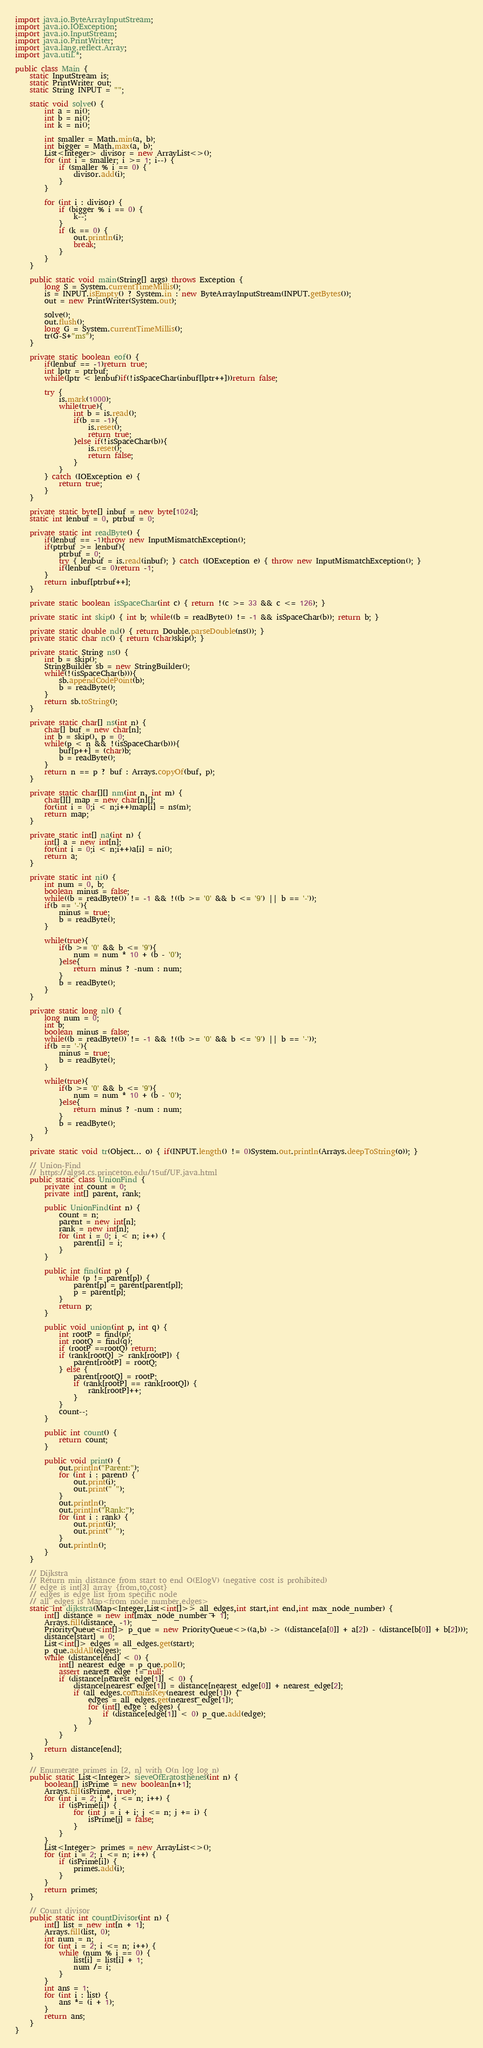Convert code to text. <code><loc_0><loc_0><loc_500><loc_500><_Java_>import java.io.ByteArrayInputStream;
import java.io.IOException;
import java.io.InputStream;
import java.io.PrintWriter;
import java.lang.reflect.Array;
import java.util.*;

public class Main {
    static InputStream is;
    static PrintWriter out;
    static String INPUT = "";

    static void solve() {
        int a = ni();
        int b = ni();
        int k = ni();

        int smaller = Math.min(a, b);
        int bigger = Math.max(a, b);
        List<Integer> divisor = new ArrayList<>();
        for (int i = smaller; i >= 1; i--) {
            if (smaller % i == 0) {
                divisor.add(i);
            }
        }

        for (int i : divisor) {
            if (bigger % i == 0) {
                k--;
            }
            if (k == 0) {
                out.println(i);
                break;
            }
        }
    }

    public static void main(String[] args) throws Exception {
        long S = System.currentTimeMillis();
        is = INPUT.isEmpty() ? System.in : new ByteArrayInputStream(INPUT.getBytes());
        out = new PrintWriter(System.out);

        solve();
        out.flush();
        long G = System.currentTimeMillis();
        tr(G-S+"ms");
    }

    private static boolean eof() {
        if(lenbuf == -1)return true;
        int lptr = ptrbuf;
        while(lptr < lenbuf)if(!isSpaceChar(inbuf[lptr++]))return false;

        try {
            is.mark(1000);
            while(true){
                int b = is.read();
                if(b == -1){
                    is.reset();
                    return true;
                }else if(!isSpaceChar(b)){
                    is.reset();
                    return false;
                }
            }
        } catch (IOException e) {
            return true;
        }
    }

    private static byte[] inbuf = new byte[1024];
    static int lenbuf = 0, ptrbuf = 0;

    private static int readByte() {
        if(lenbuf == -1)throw new InputMismatchException();
        if(ptrbuf >= lenbuf){
            ptrbuf = 0;
            try { lenbuf = is.read(inbuf); } catch (IOException e) { throw new InputMismatchException(); }
            if(lenbuf <= 0)return -1;
        }
        return inbuf[ptrbuf++];
    }

    private static boolean isSpaceChar(int c) { return !(c >= 33 && c <= 126); }

    private static int skip() { int b; while((b = readByte()) != -1 && isSpaceChar(b)); return b; }

    private static double nd() { return Double.parseDouble(ns()); }
    private static char nc() { return (char)skip(); }

    private static String ns() {
        int b = skip();
        StringBuilder sb = new StringBuilder();
        while(!(isSpaceChar(b))){
            sb.appendCodePoint(b);
            b = readByte();
        }
        return sb.toString();
    }

    private static char[] ns(int n) {
        char[] buf = new char[n];
        int b = skip(), p = 0;
        while(p < n && !(isSpaceChar(b))){
            buf[p++] = (char)b;
            b = readByte();
        }
        return n == p ? buf : Arrays.copyOf(buf, p);
    }

    private static char[][] nm(int n, int m) {
        char[][] map = new char[n][];
        for(int i = 0;i < n;i++)map[i] = ns(m);
        return map;
    }

    private static int[] na(int n) {
        int[] a = new int[n];
        for(int i = 0;i < n;i++)a[i] = ni();
        return a;
    }

    private static int ni() {
        int num = 0, b;
        boolean minus = false;
        while((b = readByte()) != -1 && !((b >= '0' && b <= '9') || b == '-'));
        if(b == '-'){
            minus = true;
            b = readByte();
        }

        while(true){
            if(b >= '0' && b <= '9'){
                num = num * 10 + (b - '0');
            }else{
                return minus ? -num : num;
            }
            b = readByte();
        }
    }

    private static long nl() {
        long num = 0;
        int b;
        boolean minus = false;
        while((b = readByte()) != -1 && !((b >= '0' && b <= '9') || b == '-'));
        if(b == '-'){
            minus = true;
            b = readByte();
        }

        while(true){
            if(b >= '0' && b <= '9'){
                num = num * 10 + (b - '0');
            }else{
                return minus ? -num : num;
            }
            b = readByte();
        }
    }

    private static void tr(Object... o) { if(INPUT.length() != 0)System.out.println(Arrays.deepToString(o)); }

    // Union-Find
    // https://algs4.cs.princeton.edu/15uf/UF.java.html
    public static class UnionFind {
        private int count = 0;
        private int[] parent, rank;

        public UnionFind(int n) {
            count = n;
            parent = new int[n];
            rank = new int[n];
            for (int i = 0; i < n; i++) {
                parent[i] = i;
            }
        }

        public int find(int p) {
            while (p != parent[p]) {
                parent[p] = parent[parent[p]];
                p = parent[p];
            }
            return p;
        }

        public void union(int p, int q) {
            int rootP = find(p);
            int rootQ = find(q);
            if (rootP ==rootQ) return;
            if (rank[rootQ] > rank[rootP]) {
                parent[rootP] = rootQ;
            } else {
                parent[rootQ] = rootP;
                if (rank[rootP] == rank[rootQ]) {
                    rank[rootP]++;
                }
            }
            count--;
        }

        public int count() {
            return count;
        }

        public void print() {
            out.println("Parent:");
            for (int i : parent) {
                out.print(i);
                out.print(" ");
            }
            out.println();
            out.println("Rank:");
            for (int i : rank) {
                out.print(i);
                out.print(" ");
            }
            out.println();
        }
    }

    // Dijkstra
    // Return min distance from start to end O(ElogV) (negative cost is prohibited)
    // edge is int[3] array {from,to,cost}
    // edges is edge list from specific node
    // all_edges is Map<from node number,edges>
    static int dijkstra(Map<Integer,List<int[]>> all_edges,int start,int end,int max_node_number) {
        int[] distance = new int[max_node_number + 1];
        Arrays.fill(distance, -1);
        PriorityQueue<int[]> p_que = new PriorityQueue<>((a,b) -> ((distance[a[0]] + a[2]) - (distance[b[0]] + b[2])));
        distance[start] = 0;
        List<int[]> edges = all_edges.get(start);
        p_que.addAll(edges);
        while (distance[end] < 0) {
            int[] nearest_edge = p_que.poll();
            assert nearest_edge != null;
            if (distance[nearest_edge[1]] < 0) {
                distance[nearest_edge[1]] = distance[nearest_edge[0]] + nearest_edge[2];
                if (all_edges.containsKey(nearest_edge[1])) {
                    edges = all_edges.get(nearest_edge[1]);
                    for (int[] edge : edges) {
                        if (distance[edge[1]] < 0) p_que.add(edge);
                    }
                }
            }
        }
        return distance[end];
    }

    // Enumerate primes in [2, n] with O(n log log n)
    public static List<Integer> sieveOfEratosthenes(int n) {
        boolean[] isPrime = new boolean[n+1];
        Arrays.fill(isPrime, true);
        for (int i = 2; i * i <= n; i++) {
            if (isPrime[i]) {
                for (int j = i + i; j <= n; j += i) {
                    isPrime[j] = false;
                }
            }
        }
        List<Integer> primes = new ArrayList<>();
        for (int i = 2; i <= n; i++) {
            if (isPrime[i]) {
                primes.add(i);
            }
        }
        return primes;
    }

    // Count divisor
    public static int countDivisor(int n) {
        int[] list = new int[n + 1];
        Arrays.fill(list, 0);
        int num = n;
        for (int i = 2; i <= n; i++) {
            while (num % i == 0) {
                list[i] = list[i] + 1;
                num /= i;
            }
        }
        int ans = 1;
        for (int i : list) {
            ans *= (i + 1);
        }
        return ans;
    }
}
</code> 